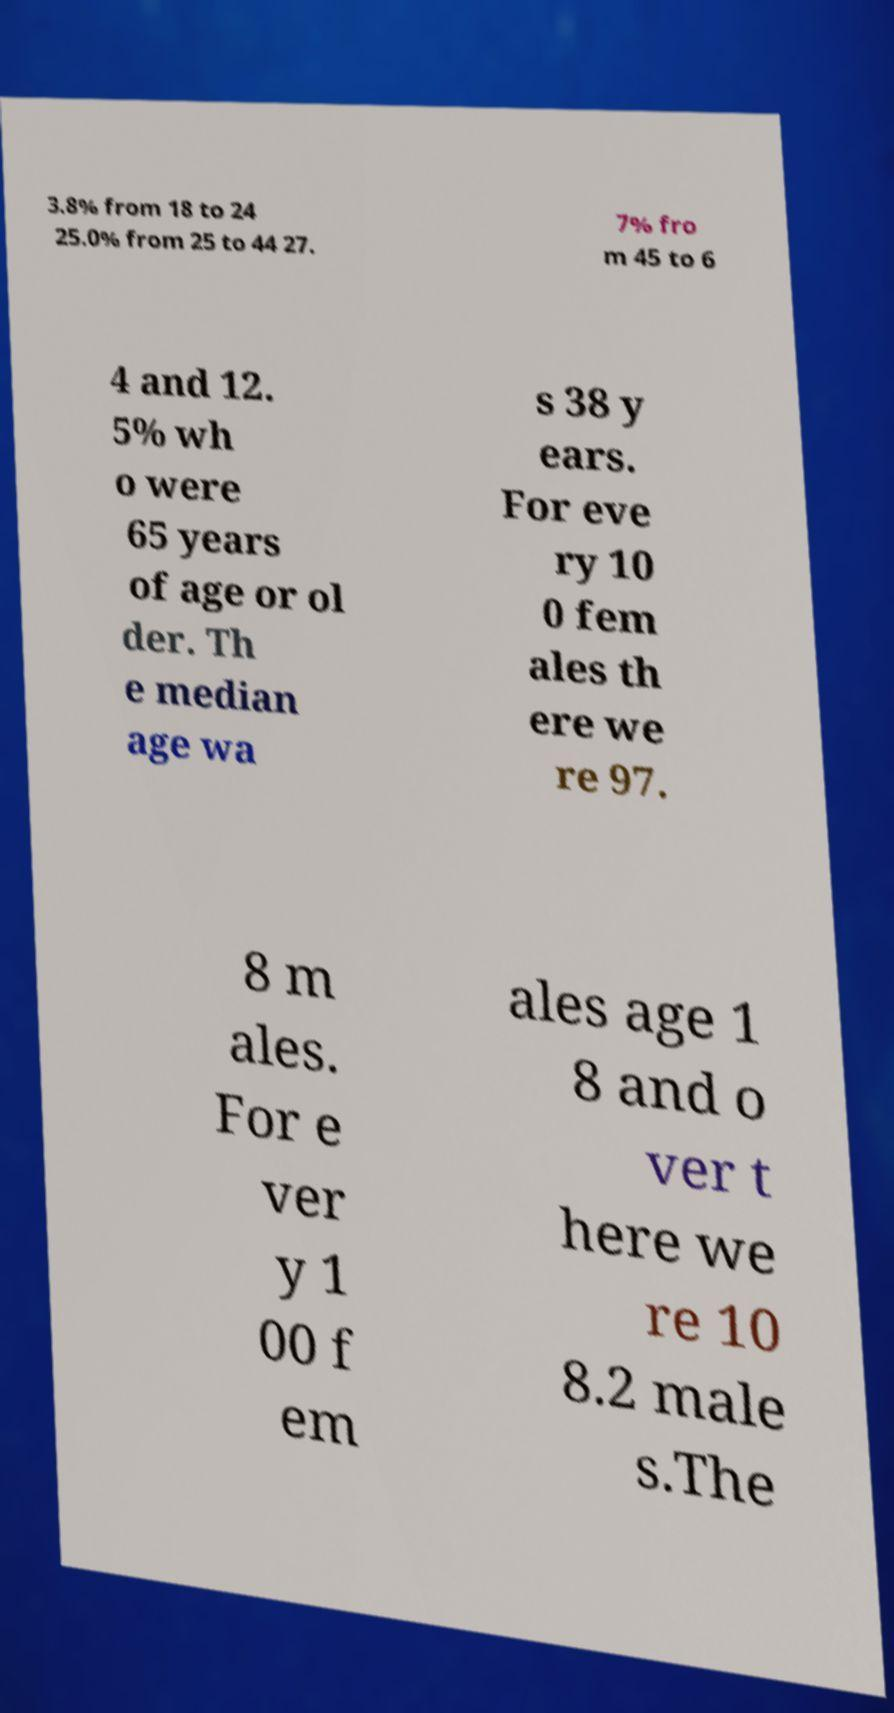Could you extract and type out the text from this image? 3.8% from 18 to 24 25.0% from 25 to 44 27. 7% fro m 45 to 6 4 and 12. 5% wh o were 65 years of age or ol der. Th e median age wa s 38 y ears. For eve ry 10 0 fem ales th ere we re 97. 8 m ales. For e ver y 1 00 f em ales age 1 8 and o ver t here we re 10 8.2 male s.The 